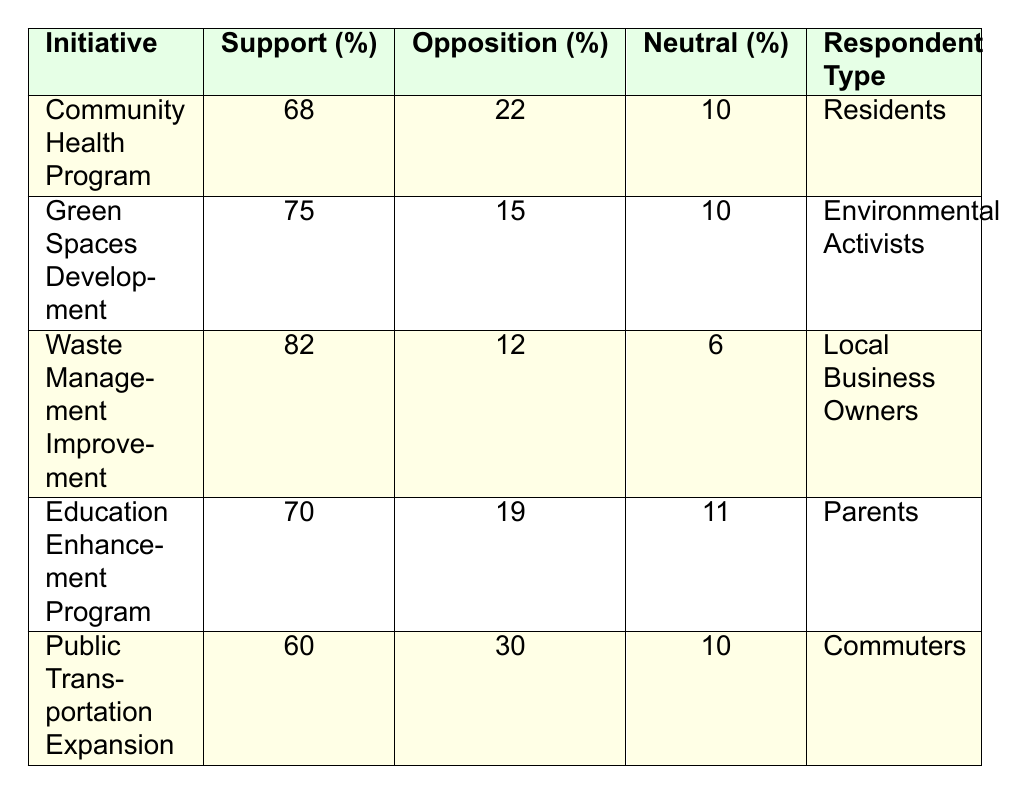What is the support percentage for the Community Health Program? The table shows that the support percentage for the Community Health Program is 68%.
Answer: 68% How many initiatives have a support percentage of 70% or higher? By reviewing the support percentages, the Community Health Program (68%), Green Spaces Development (75%), Waste Management Improvement (82%), and Education Enhancement Program (70%) are counted. There are four initiatives with a support percentage of 70% or higher.
Answer: 4 What is the opposition percentage for the Public Transportation Expansion initiative? The table indicates that the opposition percentage for the Public Transportation Expansion initiative is 30%.
Answer: 30% Which initiative has the highest support percentage? The Waste Management Improvement has the highest support percentage, listed at 82%.
Answer: Waste Management Improvement Are there more initiatives with support percentages below 70% or higher? The Community Health Program (68%), Public Transportation Expansion (60%) are below 70%. The Green Spaces Development, Waste Management Improvement, and Education Enhancement Program are above 70%. There are three initiatives below 70% and two above, so there are more initiatives below 70%.
Answer: Yes What is the average support percentage of all initiatives listed in the table? To calculate the average, sum the support percentages: (68 + 75 + 82 + 70 + 60) = 355. Then divide by the number of initiatives, which is 5. Therefore, the average support percentage is 355/5 = 71.
Answer: 71 Which respondent type shows the highest support for an initiative? The table shows the Waste Management Improvement has the highest support percentage at 82%, backed by local business owners.
Answer: Local Business Owners Is there any initiative with exactly 10% neutral responses? Upon reviewing the table, the Community Health Program and Green Spaces Development initiatives both have a neutral percentage of 10%.
Answer: Yes Compare the support percentage of the Education Enhancement Program and the Waste Management Improvement. Which one has a greater difference in support percentage? The support for Education Enhancement Program is 70% and for Waste Management Improvement is 82%. The difference is 82 - 70 = 12. Since 12 is the difference, Waste Management Improvement has a greater support percentage.
Answer: Waste Management Improvement What is the opposition percentage for both the Green Spaces Development and the Waste Management Improvement initiatives? The opposition percentage for Green Spaces Development is 15% and for Waste Management Improvement, it is 12%.
Answer: 15% and 12% What is the total percentage of support and opposition for the Public Transportation Expansion initiative? The support percentage is 60% and the opposition percentage is 30%. Adding these gives a total of 60 + 30 = 90%.
Answer: 90% 